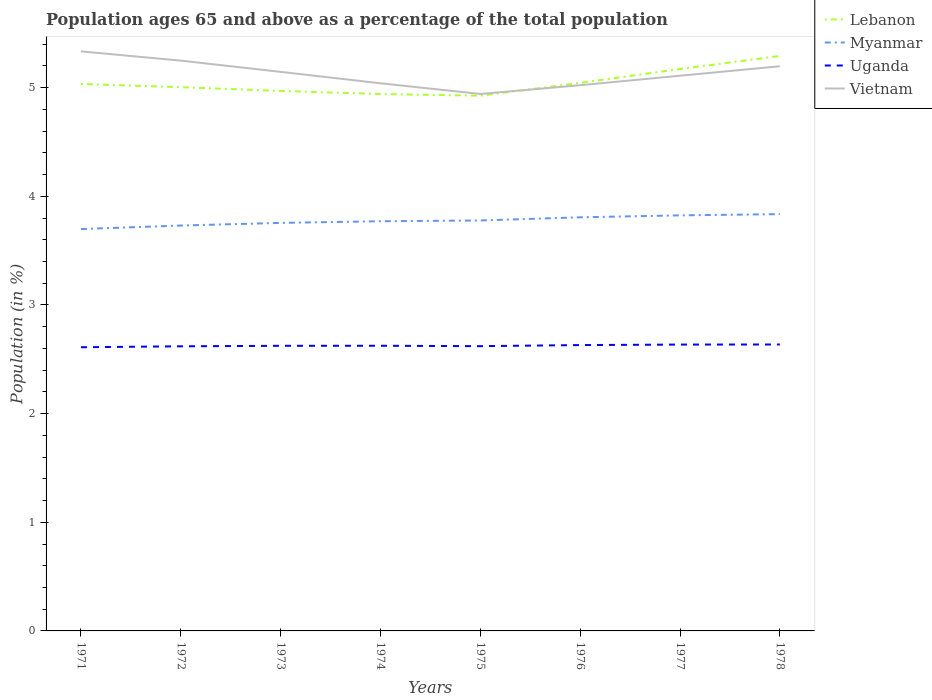How many different coloured lines are there?
Your response must be concise. 4. Does the line corresponding to Myanmar intersect with the line corresponding to Vietnam?
Make the answer very short. No. Is the number of lines equal to the number of legend labels?
Make the answer very short. Yes. Across all years, what is the maximum percentage of the population ages 65 and above in Myanmar?
Your answer should be compact. 3.7. In which year was the percentage of the population ages 65 and above in Uganda maximum?
Provide a short and direct response. 1971. What is the total percentage of the population ages 65 and above in Myanmar in the graph?
Give a very brief answer. -0.09. What is the difference between the highest and the second highest percentage of the population ages 65 and above in Lebanon?
Your answer should be compact. 0.37. How many lines are there?
Your response must be concise. 4. Are the values on the major ticks of Y-axis written in scientific E-notation?
Give a very brief answer. No. Where does the legend appear in the graph?
Make the answer very short. Top right. How many legend labels are there?
Your answer should be very brief. 4. How are the legend labels stacked?
Provide a succinct answer. Vertical. What is the title of the graph?
Provide a short and direct response. Population ages 65 and above as a percentage of the total population. What is the label or title of the Y-axis?
Keep it short and to the point. Population (in %). What is the Population (in %) of Lebanon in 1971?
Provide a succinct answer. 5.03. What is the Population (in %) in Myanmar in 1971?
Ensure brevity in your answer.  3.7. What is the Population (in %) of Uganda in 1971?
Your answer should be compact. 2.61. What is the Population (in %) of Vietnam in 1971?
Offer a very short reply. 5.33. What is the Population (in %) in Lebanon in 1972?
Ensure brevity in your answer.  5. What is the Population (in %) of Myanmar in 1972?
Your answer should be compact. 3.73. What is the Population (in %) of Uganda in 1972?
Provide a succinct answer. 2.62. What is the Population (in %) in Vietnam in 1972?
Your answer should be compact. 5.25. What is the Population (in %) in Lebanon in 1973?
Offer a terse response. 4.97. What is the Population (in %) of Myanmar in 1973?
Ensure brevity in your answer.  3.76. What is the Population (in %) of Uganda in 1973?
Offer a terse response. 2.62. What is the Population (in %) of Vietnam in 1973?
Give a very brief answer. 5.15. What is the Population (in %) in Lebanon in 1974?
Your response must be concise. 4.94. What is the Population (in %) of Myanmar in 1974?
Your answer should be compact. 3.77. What is the Population (in %) of Uganda in 1974?
Provide a short and direct response. 2.62. What is the Population (in %) in Vietnam in 1974?
Your answer should be compact. 5.04. What is the Population (in %) in Lebanon in 1975?
Offer a very short reply. 4.93. What is the Population (in %) in Myanmar in 1975?
Provide a succinct answer. 3.78. What is the Population (in %) of Uganda in 1975?
Offer a very short reply. 2.62. What is the Population (in %) of Vietnam in 1975?
Ensure brevity in your answer.  4.94. What is the Population (in %) in Lebanon in 1976?
Your answer should be very brief. 5.04. What is the Population (in %) of Myanmar in 1976?
Ensure brevity in your answer.  3.81. What is the Population (in %) of Uganda in 1976?
Make the answer very short. 2.63. What is the Population (in %) in Vietnam in 1976?
Provide a short and direct response. 5.02. What is the Population (in %) in Lebanon in 1977?
Keep it short and to the point. 5.17. What is the Population (in %) in Myanmar in 1977?
Make the answer very short. 3.82. What is the Population (in %) of Uganda in 1977?
Offer a terse response. 2.64. What is the Population (in %) of Vietnam in 1977?
Offer a very short reply. 5.11. What is the Population (in %) in Lebanon in 1978?
Your answer should be compact. 5.29. What is the Population (in %) in Myanmar in 1978?
Ensure brevity in your answer.  3.84. What is the Population (in %) of Uganda in 1978?
Give a very brief answer. 2.64. What is the Population (in %) of Vietnam in 1978?
Provide a succinct answer. 5.2. Across all years, what is the maximum Population (in %) in Lebanon?
Provide a succinct answer. 5.29. Across all years, what is the maximum Population (in %) of Myanmar?
Offer a terse response. 3.84. Across all years, what is the maximum Population (in %) in Uganda?
Offer a very short reply. 2.64. Across all years, what is the maximum Population (in %) in Vietnam?
Keep it short and to the point. 5.33. Across all years, what is the minimum Population (in %) in Lebanon?
Offer a very short reply. 4.93. Across all years, what is the minimum Population (in %) in Myanmar?
Offer a very short reply. 3.7. Across all years, what is the minimum Population (in %) in Uganda?
Keep it short and to the point. 2.61. Across all years, what is the minimum Population (in %) of Vietnam?
Ensure brevity in your answer.  4.94. What is the total Population (in %) of Lebanon in the graph?
Provide a succinct answer. 40.38. What is the total Population (in %) of Myanmar in the graph?
Keep it short and to the point. 30.2. What is the total Population (in %) in Uganda in the graph?
Make the answer very short. 21. What is the total Population (in %) in Vietnam in the graph?
Keep it short and to the point. 41.04. What is the difference between the Population (in %) in Lebanon in 1971 and that in 1972?
Your answer should be very brief. 0.03. What is the difference between the Population (in %) of Myanmar in 1971 and that in 1972?
Provide a succinct answer. -0.03. What is the difference between the Population (in %) of Uganda in 1971 and that in 1972?
Your answer should be very brief. -0.01. What is the difference between the Population (in %) in Vietnam in 1971 and that in 1972?
Keep it short and to the point. 0.09. What is the difference between the Population (in %) in Lebanon in 1971 and that in 1973?
Make the answer very short. 0.06. What is the difference between the Population (in %) in Myanmar in 1971 and that in 1973?
Offer a terse response. -0.06. What is the difference between the Population (in %) of Uganda in 1971 and that in 1973?
Provide a succinct answer. -0.01. What is the difference between the Population (in %) in Vietnam in 1971 and that in 1973?
Your response must be concise. 0.19. What is the difference between the Population (in %) of Lebanon in 1971 and that in 1974?
Give a very brief answer. 0.09. What is the difference between the Population (in %) of Myanmar in 1971 and that in 1974?
Your answer should be compact. -0.07. What is the difference between the Population (in %) in Uganda in 1971 and that in 1974?
Ensure brevity in your answer.  -0.01. What is the difference between the Population (in %) in Vietnam in 1971 and that in 1974?
Provide a succinct answer. 0.29. What is the difference between the Population (in %) of Lebanon in 1971 and that in 1975?
Offer a terse response. 0.11. What is the difference between the Population (in %) of Myanmar in 1971 and that in 1975?
Offer a very short reply. -0.08. What is the difference between the Population (in %) in Uganda in 1971 and that in 1975?
Offer a very short reply. -0.01. What is the difference between the Population (in %) in Vietnam in 1971 and that in 1975?
Make the answer very short. 0.39. What is the difference between the Population (in %) of Lebanon in 1971 and that in 1976?
Offer a terse response. -0.01. What is the difference between the Population (in %) of Myanmar in 1971 and that in 1976?
Make the answer very short. -0.11. What is the difference between the Population (in %) of Uganda in 1971 and that in 1976?
Offer a terse response. -0.02. What is the difference between the Population (in %) of Vietnam in 1971 and that in 1976?
Give a very brief answer. 0.31. What is the difference between the Population (in %) in Lebanon in 1971 and that in 1977?
Provide a succinct answer. -0.14. What is the difference between the Population (in %) in Myanmar in 1971 and that in 1977?
Offer a terse response. -0.13. What is the difference between the Population (in %) in Uganda in 1971 and that in 1977?
Your answer should be very brief. -0.02. What is the difference between the Population (in %) of Vietnam in 1971 and that in 1977?
Your answer should be compact. 0.22. What is the difference between the Population (in %) in Lebanon in 1971 and that in 1978?
Provide a short and direct response. -0.26. What is the difference between the Population (in %) of Myanmar in 1971 and that in 1978?
Your answer should be compact. -0.14. What is the difference between the Population (in %) of Uganda in 1971 and that in 1978?
Provide a short and direct response. -0.03. What is the difference between the Population (in %) in Vietnam in 1971 and that in 1978?
Make the answer very short. 0.14. What is the difference between the Population (in %) of Lebanon in 1972 and that in 1973?
Your response must be concise. 0.03. What is the difference between the Population (in %) in Myanmar in 1972 and that in 1973?
Make the answer very short. -0.02. What is the difference between the Population (in %) in Uganda in 1972 and that in 1973?
Your answer should be compact. -0. What is the difference between the Population (in %) in Vietnam in 1972 and that in 1973?
Make the answer very short. 0.1. What is the difference between the Population (in %) of Lebanon in 1972 and that in 1974?
Your answer should be compact. 0.06. What is the difference between the Population (in %) in Myanmar in 1972 and that in 1974?
Your response must be concise. -0.04. What is the difference between the Population (in %) of Uganda in 1972 and that in 1974?
Offer a very short reply. -0.01. What is the difference between the Population (in %) of Vietnam in 1972 and that in 1974?
Keep it short and to the point. 0.21. What is the difference between the Population (in %) in Lebanon in 1972 and that in 1975?
Your answer should be very brief. 0.08. What is the difference between the Population (in %) of Myanmar in 1972 and that in 1975?
Your response must be concise. -0.05. What is the difference between the Population (in %) of Uganda in 1972 and that in 1975?
Your answer should be compact. -0. What is the difference between the Population (in %) in Vietnam in 1972 and that in 1975?
Keep it short and to the point. 0.31. What is the difference between the Population (in %) of Lebanon in 1972 and that in 1976?
Provide a succinct answer. -0.04. What is the difference between the Population (in %) of Myanmar in 1972 and that in 1976?
Provide a succinct answer. -0.08. What is the difference between the Population (in %) of Uganda in 1972 and that in 1976?
Your response must be concise. -0.01. What is the difference between the Population (in %) in Vietnam in 1972 and that in 1976?
Offer a very short reply. 0.23. What is the difference between the Population (in %) of Lebanon in 1972 and that in 1977?
Your answer should be very brief. -0.17. What is the difference between the Population (in %) in Myanmar in 1972 and that in 1977?
Your response must be concise. -0.09. What is the difference between the Population (in %) of Uganda in 1972 and that in 1977?
Keep it short and to the point. -0.02. What is the difference between the Population (in %) of Vietnam in 1972 and that in 1977?
Your response must be concise. 0.14. What is the difference between the Population (in %) of Lebanon in 1972 and that in 1978?
Keep it short and to the point. -0.29. What is the difference between the Population (in %) of Myanmar in 1972 and that in 1978?
Your answer should be compact. -0.1. What is the difference between the Population (in %) in Uganda in 1972 and that in 1978?
Provide a succinct answer. -0.02. What is the difference between the Population (in %) in Vietnam in 1972 and that in 1978?
Provide a short and direct response. 0.05. What is the difference between the Population (in %) in Lebanon in 1973 and that in 1974?
Provide a succinct answer. 0.03. What is the difference between the Population (in %) of Myanmar in 1973 and that in 1974?
Your answer should be very brief. -0.02. What is the difference between the Population (in %) in Uganda in 1973 and that in 1974?
Your answer should be very brief. -0. What is the difference between the Population (in %) of Vietnam in 1973 and that in 1974?
Ensure brevity in your answer.  0.11. What is the difference between the Population (in %) in Lebanon in 1973 and that in 1975?
Give a very brief answer. 0.04. What is the difference between the Population (in %) in Myanmar in 1973 and that in 1975?
Ensure brevity in your answer.  -0.02. What is the difference between the Population (in %) in Uganda in 1973 and that in 1975?
Ensure brevity in your answer.  0. What is the difference between the Population (in %) of Vietnam in 1973 and that in 1975?
Make the answer very short. 0.2. What is the difference between the Population (in %) of Lebanon in 1973 and that in 1976?
Keep it short and to the point. -0.07. What is the difference between the Population (in %) in Myanmar in 1973 and that in 1976?
Keep it short and to the point. -0.05. What is the difference between the Population (in %) of Uganda in 1973 and that in 1976?
Provide a succinct answer. -0.01. What is the difference between the Population (in %) of Vietnam in 1973 and that in 1976?
Your answer should be very brief. 0.12. What is the difference between the Population (in %) of Lebanon in 1973 and that in 1977?
Ensure brevity in your answer.  -0.2. What is the difference between the Population (in %) in Myanmar in 1973 and that in 1977?
Ensure brevity in your answer.  -0.07. What is the difference between the Population (in %) of Uganda in 1973 and that in 1977?
Give a very brief answer. -0.01. What is the difference between the Population (in %) in Vietnam in 1973 and that in 1977?
Ensure brevity in your answer.  0.04. What is the difference between the Population (in %) in Lebanon in 1973 and that in 1978?
Keep it short and to the point. -0.32. What is the difference between the Population (in %) in Myanmar in 1973 and that in 1978?
Your response must be concise. -0.08. What is the difference between the Population (in %) of Uganda in 1973 and that in 1978?
Keep it short and to the point. -0.01. What is the difference between the Population (in %) of Vietnam in 1973 and that in 1978?
Your answer should be compact. -0.05. What is the difference between the Population (in %) in Lebanon in 1974 and that in 1975?
Offer a terse response. 0.02. What is the difference between the Population (in %) of Myanmar in 1974 and that in 1975?
Your answer should be very brief. -0.01. What is the difference between the Population (in %) in Uganda in 1974 and that in 1975?
Your response must be concise. 0. What is the difference between the Population (in %) in Vietnam in 1974 and that in 1975?
Your answer should be very brief. 0.1. What is the difference between the Population (in %) of Lebanon in 1974 and that in 1976?
Your answer should be compact. -0.1. What is the difference between the Population (in %) in Myanmar in 1974 and that in 1976?
Provide a short and direct response. -0.04. What is the difference between the Population (in %) in Uganda in 1974 and that in 1976?
Ensure brevity in your answer.  -0.01. What is the difference between the Population (in %) in Vietnam in 1974 and that in 1976?
Make the answer very short. 0.02. What is the difference between the Population (in %) of Lebanon in 1974 and that in 1977?
Offer a very short reply. -0.23. What is the difference between the Population (in %) of Myanmar in 1974 and that in 1977?
Provide a short and direct response. -0.05. What is the difference between the Population (in %) in Uganda in 1974 and that in 1977?
Offer a terse response. -0.01. What is the difference between the Population (in %) of Vietnam in 1974 and that in 1977?
Offer a terse response. -0.07. What is the difference between the Population (in %) in Lebanon in 1974 and that in 1978?
Provide a succinct answer. -0.35. What is the difference between the Population (in %) in Myanmar in 1974 and that in 1978?
Ensure brevity in your answer.  -0.07. What is the difference between the Population (in %) of Uganda in 1974 and that in 1978?
Provide a succinct answer. -0.01. What is the difference between the Population (in %) of Vietnam in 1974 and that in 1978?
Offer a terse response. -0.16. What is the difference between the Population (in %) of Lebanon in 1975 and that in 1976?
Your answer should be compact. -0.12. What is the difference between the Population (in %) of Myanmar in 1975 and that in 1976?
Offer a very short reply. -0.03. What is the difference between the Population (in %) in Uganda in 1975 and that in 1976?
Make the answer very short. -0.01. What is the difference between the Population (in %) in Vietnam in 1975 and that in 1976?
Offer a terse response. -0.08. What is the difference between the Population (in %) of Lebanon in 1975 and that in 1977?
Ensure brevity in your answer.  -0.25. What is the difference between the Population (in %) in Myanmar in 1975 and that in 1977?
Give a very brief answer. -0.05. What is the difference between the Population (in %) in Uganda in 1975 and that in 1977?
Offer a terse response. -0.01. What is the difference between the Population (in %) in Vietnam in 1975 and that in 1977?
Provide a short and direct response. -0.17. What is the difference between the Population (in %) in Lebanon in 1975 and that in 1978?
Give a very brief answer. -0.37. What is the difference between the Population (in %) of Myanmar in 1975 and that in 1978?
Offer a very short reply. -0.06. What is the difference between the Population (in %) of Uganda in 1975 and that in 1978?
Offer a very short reply. -0.02. What is the difference between the Population (in %) in Vietnam in 1975 and that in 1978?
Make the answer very short. -0.25. What is the difference between the Population (in %) of Lebanon in 1976 and that in 1977?
Your answer should be very brief. -0.13. What is the difference between the Population (in %) of Myanmar in 1976 and that in 1977?
Your answer should be very brief. -0.02. What is the difference between the Population (in %) in Uganda in 1976 and that in 1977?
Ensure brevity in your answer.  -0. What is the difference between the Population (in %) of Vietnam in 1976 and that in 1977?
Give a very brief answer. -0.09. What is the difference between the Population (in %) of Lebanon in 1976 and that in 1978?
Ensure brevity in your answer.  -0.25. What is the difference between the Population (in %) in Myanmar in 1976 and that in 1978?
Offer a very short reply. -0.03. What is the difference between the Population (in %) in Uganda in 1976 and that in 1978?
Your response must be concise. -0.01. What is the difference between the Population (in %) of Vietnam in 1976 and that in 1978?
Keep it short and to the point. -0.17. What is the difference between the Population (in %) of Lebanon in 1977 and that in 1978?
Keep it short and to the point. -0.12. What is the difference between the Population (in %) of Myanmar in 1977 and that in 1978?
Your answer should be compact. -0.01. What is the difference between the Population (in %) in Uganda in 1977 and that in 1978?
Ensure brevity in your answer.  -0. What is the difference between the Population (in %) of Vietnam in 1977 and that in 1978?
Your answer should be very brief. -0.09. What is the difference between the Population (in %) in Lebanon in 1971 and the Population (in %) in Myanmar in 1972?
Give a very brief answer. 1.3. What is the difference between the Population (in %) in Lebanon in 1971 and the Population (in %) in Uganda in 1972?
Give a very brief answer. 2.41. What is the difference between the Population (in %) in Lebanon in 1971 and the Population (in %) in Vietnam in 1972?
Ensure brevity in your answer.  -0.22. What is the difference between the Population (in %) of Myanmar in 1971 and the Population (in %) of Uganda in 1972?
Keep it short and to the point. 1.08. What is the difference between the Population (in %) in Myanmar in 1971 and the Population (in %) in Vietnam in 1972?
Ensure brevity in your answer.  -1.55. What is the difference between the Population (in %) of Uganda in 1971 and the Population (in %) of Vietnam in 1972?
Provide a succinct answer. -2.64. What is the difference between the Population (in %) in Lebanon in 1971 and the Population (in %) in Myanmar in 1973?
Your response must be concise. 1.28. What is the difference between the Population (in %) of Lebanon in 1971 and the Population (in %) of Uganda in 1973?
Provide a short and direct response. 2.41. What is the difference between the Population (in %) of Lebanon in 1971 and the Population (in %) of Vietnam in 1973?
Provide a short and direct response. -0.11. What is the difference between the Population (in %) of Myanmar in 1971 and the Population (in %) of Uganda in 1973?
Provide a succinct answer. 1.07. What is the difference between the Population (in %) of Myanmar in 1971 and the Population (in %) of Vietnam in 1973?
Your answer should be compact. -1.45. What is the difference between the Population (in %) of Uganda in 1971 and the Population (in %) of Vietnam in 1973?
Provide a succinct answer. -2.53. What is the difference between the Population (in %) of Lebanon in 1971 and the Population (in %) of Myanmar in 1974?
Give a very brief answer. 1.26. What is the difference between the Population (in %) of Lebanon in 1971 and the Population (in %) of Uganda in 1974?
Make the answer very short. 2.41. What is the difference between the Population (in %) of Lebanon in 1971 and the Population (in %) of Vietnam in 1974?
Your answer should be compact. -0.01. What is the difference between the Population (in %) in Myanmar in 1971 and the Population (in %) in Uganda in 1974?
Make the answer very short. 1.07. What is the difference between the Population (in %) in Myanmar in 1971 and the Population (in %) in Vietnam in 1974?
Your response must be concise. -1.34. What is the difference between the Population (in %) in Uganda in 1971 and the Population (in %) in Vietnam in 1974?
Ensure brevity in your answer.  -2.43. What is the difference between the Population (in %) of Lebanon in 1971 and the Population (in %) of Myanmar in 1975?
Give a very brief answer. 1.26. What is the difference between the Population (in %) in Lebanon in 1971 and the Population (in %) in Uganda in 1975?
Your answer should be compact. 2.41. What is the difference between the Population (in %) in Lebanon in 1971 and the Population (in %) in Vietnam in 1975?
Ensure brevity in your answer.  0.09. What is the difference between the Population (in %) in Myanmar in 1971 and the Population (in %) in Uganda in 1975?
Ensure brevity in your answer.  1.08. What is the difference between the Population (in %) of Myanmar in 1971 and the Population (in %) of Vietnam in 1975?
Offer a terse response. -1.24. What is the difference between the Population (in %) of Uganda in 1971 and the Population (in %) of Vietnam in 1975?
Offer a very short reply. -2.33. What is the difference between the Population (in %) in Lebanon in 1971 and the Population (in %) in Myanmar in 1976?
Your response must be concise. 1.23. What is the difference between the Population (in %) in Lebanon in 1971 and the Population (in %) in Uganda in 1976?
Offer a very short reply. 2.4. What is the difference between the Population (in %) in Lebanon in 1971 and the Population (in %) in Vietnam in 1976?
Provide a succinct answer. 0.01. What is the difference between the Population (in %) in Myanmar in 1971 and the Population (in %) in Uganda in 1976?
Offer a terse response. 1.07. What is the difference between the Population (in %) in Myanmar in 1971 and the Population (in %) in Vietnam in 1976?
Ensure brevity in your answer.  -1.32. What is the difference between the Population (in %) of Uganda in 1971 and the Population (in %) of Vietnam in 1976?
Offer a very short reply. -2.41. What is the difference between the Population (in %) of Lebanon in 1971 and the Population (in %) of Myanmar in 1977?
Your answer should be compact. 1.21. What is the difference between the Population (in %) of Lebanon in 1971 and the Population (in %) of Uganda in 1977?
Provide a short and direct response. 2.4. What is the difference between the Population (in %) of Lebanon in 1971 and the Population (in %) of Vietnam in 1977?
Give a very brief answer. -0.08. What is the difference between the Population (in %) in Myanmar in 1971 and the Population (in %) in Uganda in 1977?
Offer a very short reply. 1.06. What is the difference between the Population (in %) in Myanmar in 1971 and the Population (in %) in Vietnam in 1977?
Offer a terse response. -1.41. What is the difference between the Population (in %) in Uganda in 1971 and the Population (in %) in Vietnam in 1977?
Keep it short and to the point. -2.5. What is the difference between the Population (in %) in Lebanon in 1971 and the Population (in %) in Myanmar in 1978?
Your answer should be compact. 1.2. What is the difference between the Population (in %) of Lebanon in 1971 and the Population (in %) of Uganda in 1978?
Provide a succinct answer. 2.4. What is the difference between the Population (in %) in Lebanon in 1971 and the Population (in %) in Vietnam in 1978?
Give a very brief answer. -0.16. What is the difference between the Population (in %) of Myanmar in 1971 and the Population (in %) of Uganda in 1978?
Provide a short and direct response. 1.06. What is the difference between the Population (in %) of Myanmar in 1971 and the Population (in %) of Vietnam in 1978?
Provide a succinct answer. -1.5. What is the difference between the Population (in %) of Uganda in 1971 and the Population (in %) of Vietnam in 1978?
Ensure brevity in your answer.  -2.59. What is the difference between the Population (in %) in Lebanon in 1972 and the Population (in %) in Myanmar in 1973?
Provide a succinct answer. 1.25. What is the difference between the Population (in %) of Lebanon in 1972 and the Population (in %) of Uganda in 1973?
Offer a terse response. 2.38. What is the difference between the Population (in %) in Lebanon in 1972 and the Population (in %) in Vietnam in 1973?
Your answer should be very brief. -0.14. What is the difference between the Population (in %) of Myanmar in 1972 and the Population (in %) of Uganda in 1973?
Offer a terse response. 1.11. What is the difference between the Population (in %) in Myanmar in 1972 and the Population (in %) in Vietnam in 1973?
Give a very brief answer. -1.41. What is the difference between the Population (in %) of Uganda in 1972 and the Population (in %) of Vietnam in 1973?
Your answer should be very brief. -2.53. What is the difference between the Population (in %) in Lebanon in 1972 and the Population (in %) in Myanmar in 1974?
Offer a very short reply. 1.23. What is the difference between the Population (in %) of Lebanon in 1972 and the Population (in %) of Uganda in 1974?
Give a very brief answer. 2.38. What is the difference between the Population (in %) of Lebanon in 1972 and the Population (in %) of Vietnam in 1974?
Provide a succinct answer. -0.04. What is the difference between the Population (in %) of Myanmar in 1972 and the Population (in %) of Uganda in 1974?
Give a very brief answer. 1.11. What is the difference between the Population (in %) of Myanmar in 1972 and the Population (in %) of Vietnam in 1974?
Your response must be concise. -1.31. What is the difference between the Population (in %) of Uganda in 1972 and the Population (in %) of Vietnam in 1974?
Ensure brevity in your answer.  -2.42. What is the difference between the Population (in %) of Lebanon in 1972 and the Population (in %) of Myanmar in 1975?
Provide a short and direct response. 1.23. What is the difference between the Population (in %) of Lebanon in 1972 and the Population (in %) of Uganda in 1975?
Make the answer very short. 2.38. What is the difference between the Population (in %) in Lebanon in 1972 and the Population (in %) in Vietnam in 1975?
Provide a short and direct response. 0.06. What is the difference between the Population (in %) of Myanmar in 1972 and the Population (in %) of Uganda in 1975?
Provide a succinct answer. 1.11. What is the difference between the Population (in %) of Myanmar in 1972 and the Population (in %) of Vietnam in 1975?
Provide a short and direct response. -1.21. What is the difference between the Population (in %) in Uganda in 1972 and the Population (in %) in Vietnam in 1975?
Keep it short and to the point. -2.32. What is the difference between the Population (in %) of Lebanon in 1972 and the Population (in %) of Myanmar in 1976?
Keep it short and to the point. 1.2. What is the difference between the Population (in %) of Lebanon in 1972 and the Population (in %) of Uganda in 1976?
Offer a terse response. 2.37. What is the difference between the Population (in %) of Lebanon in 1972 and the Population (in %) of Vietnam in 1976?
Offer a very short reply. -0.02. What is the difference between the Population (in %) of Myanmar in 1972 and the Population (in %) of Uganda in 1976?
Provide a succinct answer. 1.1. What is the difference between the Population (in %) in Myanmar in 1972 and the Population (in %) in Vietnam in 1976?
Your answer should be compact. -1.29. What is the difference between the Population (in %) in Uganda in 1972 and the Population (in %) in Vietnam in 1976?
Give a very brief answer. -2.4. What is the difference between the Population (in %) in Lebanon in 1972 and the Population (in %) in Myanmar in 1977?
Your answer should be compact. 1.18. What is the difference between the Population (in %) in Lebanon in 1972 and the Population (in %) in Uganda in 1977?
Keep it short and to the point. 2.37. What is the difference between the Population (in %) in Lebanon in 1972 and the Population (in %) in Vietnam in 1977?
Offer a very short reply. -0.11. What is the difference between the Population (in %) in Myanmar in 1972 and the Population (in %) in Uganda in 1977?
Your answer should be very brief. 1.1. What is the difference between the Population (in %) of Myanmar in 1972 and the Population (in %) of Vietnam in 1977?
Ensure brevity in your answer.  -1.38. What is the difference between the Population (in %) of Uganda in 1972 and the Population (in %) of Vietnam in 1977?
Provide a succinct answer. -2.49. What is the difference between the Population (in %) in Lebanon in 1972 and the Population (in %) in Myanmar in 1978?
Provide a short and direct response. 1.17. What is the difference between the Population (in %) in Lebanon in 1972 and the Population (in %) in Uganda in 1978?
Provide a short and direct response. 2.37. What is the difference between the Population (in %) in Lebanon in 1972 and the Population (in %) in Vietnam in 1978?
Your response must be concise. -0.19. What is the difference between the Population (in %) of Myanmar in 1972 and the Population (in %) of Uganda in 1978?
Give a very brief answer. 1.09. What is the difference between the Population (in %) in Myanmar in 1972 and the Population (in %) in Vietnam in 1978?
Offer a very short reply. -1.47. What is the difference between the Population (in %) in Uganda in 1972 and the Population (in %) in Vietnam in 1978?
Provide a succinct answer. -2.58. What is the difference between the Population (in %) of Lebanon in 1973 and the Population (in %) of Myanmar in 1974?
Make the answer very short. 1.2. What is the difference between the Population (in %) in Lebanon in 1973 and the Population (in %) in Uganda in 1974?
Your answer should be compact. 2.35. What is the difference between the Population (in %) of Lebanon in 1973 and the Population (in %) of Vietnam in 1974?
Provide a succinct answer. -0.07. What is the difference between the Population (in %) of Myanmar in 1973 and the Population (in %) of Uganda in 1974?
Your answer should be compact. 1.13. What is the difference between the Population (in %) in Myanmar in 1973 and the Population (in %) in Vietnam in 1974?
Ensure brevity in your answer.  -1.28. What is the difference between the Population (in %) in Uganda in 1973 and the Population (in %) in Vietnam in 1974?
Provide a short and direct response. -2.42. What is the difference between the Population (in %) of Lebanon in 1973 and the Population (in %) of Myanmar in 1975?
Your response must be concise. 1.19. What is the difference between the Population (in %) of Lebanon in 1973 and the Population (in %) of Uganda in 1975?
Your response must be concise. 2.35. What is the difference between the Population (in %) in Lebanon in 1973 and the Population (in %) in Vietnam in 1975?
Offer a terse response. 0.03. What is the difference between the Population (in %) in Myanmar in 1973 and the Population (in %) in Uganda in 1975?
Ensure brevity in your answer.  1.13. What is the difference between the Population (in %) in Myanmar in 1973 and the Population (in %) in Vietnam in 1975?
Your response must be concise. -1.19. What is the difference between the Population (in %) in Uganda in 1973 and the Population (in %) in Vietnam in 1975?
Your answer should be very brief. -2.32. What is the difference between the Population (in %) of Lebanon in 1973 and the Population (in %) of Myanmar in 1976?
Your answer should be very brief. 1.16. What is the difference between the Population (in %) of Lebanon in 1973 and the Population (in %) of Uganda in 1976?
Keep it short and to the point. 2.34. What is the difference between the Population (in %) of Lebanon in 1973 and the Population (in %) of Vietnam in 1976?
Provide a succinct answer. -0.05. What is the difference between the Population (in %) in Myanmar in 1973 and the Population (in %) in Uganda in 1976?
Offer a terse response. 1.12. What is the difference between the Population (in %) of Myanmar in 1973 and the Population (in %) of Vietnam in 1976?
Give a very brief answer. -1.27. What is the difference between the Population (in %) of Uganda in 1973 and the Population (in %) of Vietnam in 1976?
Keep it short and to the point. -2.4. What is the difference between the Population (in %) of Lebanon in 1973 and the Population (in %) of Myanmar in 1977?
Keep it short and to the point. 1.15. What is the difference between the Population (in %) of Lebanon in 1973 and the Population (in %) of Uganda in 1977?
Provide a succinct answer. 2.33. What is the difference between the Population (in %) in Lebanon in 1973 and the Population (in %) in Vietnam in 1977?
Give a very brief answer. -0.14. What is the difference between the Population (in %) in Myanmar in 1973 and the Population (in %) in Uganda in 1977?
Ensure brevity in your answer.  1.12. What is the difference between the Population (in %) of Myanmar in 1973 and the Population (in %) of Vietnam in 1977?
Your answer should be very brief. -1.35. What is the difference between the Population (in %) in Uganda in 1973 and the Population (in %) in Vietnam in 1977?
Your answer should be very brief. -2.49. What is the difference between the Population (in %) in Lebanon in 1973 and the Population (in %) in Myanmar in 1978?
Offer a very short reply. 1.13. What is the difference between the Population (in %) in Lebanon in 1973 and the Population (in %) in Uganda in 1978?
Give a very brief answer. 2.33. What is the difference between the Population (in %) in Lebanon in 1973 and the Population (in %) in Vietnam in 1978?
Your answer should be compact. -0.23. What is the difference between the Population (in %) in Myanmar in 1973 and the Population (in %) in Uganda in 1978?
Provide a succinct answer. 1.12. What is the difference between the Population (in %) of Myanmar in 1973 and the Population (in %) of Vietnam in 1978?
Offer a terse response. -1.44. What is the difference between the Population (in %) of Uganda in 1973 and the Population (in %) of Vietnam in 1978?
Your answer should be very brief. -2.57. What is the difference between the Population (in %) of Lebanon in 1974 and the Population (in %) of Myanmar in 1975?
Make the answer very short. 1.16. What is the difference between the Population (in %) of Lebanon in 1974 and the Population (in %) of Uganda in 1975?
Provide a short and direct response. 2.32. What is the difference between the Population (in %) in Lebanon in 1974 and the Population (in %) in Vietnam in 1975?
Keep it short and to the point. -0. What is the difference between the Population (in %) of Myanmar in 1974 and the Population (in %) of Uganda in 1975?
Your answer should be very brief. 1.15. What is the difference between the Population (in %) in Myanmar in 1974 and the Population (in %) in Vietnam in 1975?
Your answer should be very brief. -1.17. What is the difference between the Population (in %) in Uganda in 1974 and the Population (in %) in Vietnam in 1975?
Provide a succinct answer. -2.32. What is the difference between the Population (in %) of Lebanon in 1974 and the Population (in %) of Myanmar in 1976?
Offer a terse response. 1.13. What is the difference between the Population (in %) in Lebanon in 1974 and the Population (in %) in Uganda in 1976?
Give a very brief answer. 2.31. What is the difference between the Population (in %) in Lebanon in 1974 and the Population (in %) in Vietnam in 1976?
Ensure brevity in your answer.  -0.08. What is the difference between the Population (in %) in Myanmar in 1974 and the Population (in %) in Uganda in 1976?
Keep it short and to the point. 1.14. What is the difference between the Population (in %) of Myanmar in 1974 and the Population (in %) of Vietnam in 1976?
Offer a very short reply. -1.25. What is the difference between the Population (in %) in Uganda in 1974 and the Population (in %) in Vietnam in 1976?
Keep it short and to the point. -2.4. What is the difference between the Population (in %) of Lebanon in 1974 and the Population (in %) of Myanmar in 1977?
Ensure brevity in your answer.  1.12. What is the difference between the Population (in %) of Lebanon in 1974 and the Population (in %) of Uganda in 1977?
Provide a short and direct response. 2.31. What is the difference between the Population (in %) of Lebanon in 1974 and the Population (in %) of Vietnam in 1977?
Offer a terse response. -0.17. What is the difference between the Population (in %) of Myanmar in 1974 and the Population (in %) of Uganda in 1977?
Give a very brief answer. 1.14. What is the difference between the Population (in %) of Myanmar in 1974 and the Population (in %) of Vietnam in 1977?
Ensure brevity in your answer.  -1.34. What is the difference between the Population (in %) in Uganda in 1974 and the Population (in %) in Vietnam in 1977?
Your response must be concise. -2.49. What is the difference between the Population (in %) in Lebanon in 1974 and the Population (in %) in Myanmar in 1978?
Provide a short and direct response. 1.11. What is the difference between the Population (in %) of Lebanon in 1974 and the Population (in %) of Uganda in 1978?
Provide a short and direct response. 2.31. What is the difference between the Population (in %) in Lebanon in 1974 and the Population (in %) in Vietnam in 1978?
Offer a very short reply. -0.26. What is the difference between the Population (in %) in Myanmar in 1974 and the Population (in %) in Uganda in 1978?
Offer a very short reply. 1.13. What is the difference between the Population (in %) of Myanmar in 1974 and the Population (in %) of Vietnam in 1978?
Keep it short and to the point. -1.43. What is the difference between the Population (in %) of Uganda in 1974 and the Population (in %) of Vietnam in 1978?
Give a very brief answer. -2.57. What is the difference between the Population (in %) of Lebanon in 1975 and the Population (in %) of Myanmar in 1976?
Offer a very short reply. 1.12. What is the difference between the Population (in %) in Lebanon in 1975 and the Population (in %) in Uganda in 1976?
Provide a short and direct response. 2.3. What is the difference between the Population (in %) of Lebanon in 1975 and the Population (in %) of Vietnam in 1976?
Offer a very short reply. -0.1. What is the difference between the Population (in %) in Myanmar in 1975 and the Population (in %) in Uganda in 1976?
Offer a very short reply. 1.15. What is the difference between the Population (in %) of Myanmar in 1975 and the Population (in %) of Vietnam in 1976?
Make the answer very short. -1.24. What is the difference between the Population (in %) in Uganda in 1975 and the Population (in %) in Vietnam in 1976?
Keep it short and to the point. -2.4. What is the difference between the Population (in %) in Lebanon in 1975 and the Population (in %) in Myanmar in 1977?
Your answer should be compact. 1.1. What is the difference between the Population (in %) in Lebanon in 1975 and the Population (in %) in Uganda in 1977?
Make the answer very short. 2.29. What is the difference between the Population (in %) in Lebanon in 1975 and the Population (in %) in Vietnam in 1977?
Offer a terse response. -0.18. What is the difference between the Population (in %) in Myanmar in 1975 and the Population (in %) in Uganda in 1977?
Your answer should be compact. 1.14. What is the difference between the Population (in %) of Myanmar in 1975 and the Population (in %) of Vietnam in 1977?
Your response must be concise. -1.33. What is the difference between the Population (in %) in Uganda in 1975 and the Population (in %) in Vietnam in 1977?
Offer a terse response. -2.49. What is the difference between the Population (in %) in Lebanon in 1975 and the Population (in %) in Myanmar in 1978?
Ensure brevity in your answer.  1.09. What is the difference between the Population (in %) of Lebanon in 1975 and the Population (in %) of Uganda in 1978?
Keep it short and to the point. 2.29. What is the difference between the Population (in %) of Lebanon in 1975 and the Population (in %) of Vietnam in 1978?
Give a very brief answer. -0.27. What is the difference between the Population (in %) of Myanmar in 1975 and the Population (in %) of Uganda in 1978?
Make the answer very short. 1.14. What is the difference between the Population (in %) in Myanmar in 1975 and the Population (in %) in Vietnam in 1978?
Provide a short and direct response. -1.42. What is the difference between the Population (in %) in Uganda in 1975 and the Population (in %) in Vietnam in 1978?
Your response must be concise. -2.58. What is the difference between the Population (in %) of Lebanon in 1976 and the Population (in %) of Myanmar in 1977?
Make the answer very short. 1.22. What is the difference between the Population (in %) of Lebanon in 1976 and the Population (in %) of Uganda in 1977?
Your answer should be compact. 2.41. What is the difference between the Population (in %) of Lebanon in 1976 and the Population (in %) of Vietnam in 1977?
Offer a terse response. -0.07. What is the difference between the Population (in %) in Myanmar in 1976 and the Population (in %) in Uganda in 1977?
Offer a terse response. 1.17. What is the difference between the Population (in %) in Myanmar in 1976 and the Population (in %) in Vietnam in 1977?
Your response must be concise. -1.3. What is the difference between the Population (in %) of Uganda in 1976 and the Population (in %) of Vietnam in 1977?
Offer a very short reply. -2.48. What is the difference between the Population (in %) of Lebanon in 1976 and the Population (in %) of Myanmar in 1978?
Your answer should be compact. 1.21. What is the difference between the Population (in %) of Lebanon in 1976 and the Population (in %) of Uganda in 1978?
Give a very brief answer. 2.41. What is the difference between the Population (in %) of Lebanon in 1976 and the Population (in %) of Vietnam in 1978?
Offer a terse response. -0.15. What is the difference between the Population (in %) of Myanmar in 1976 and the Population (in %) of Uganda in 1978?
Give a very brief answer. 1.17. What is the difference between the Population (in %) of Myanmar in 1976 and the Population (in %) of Vietnam in 1978?
Give a very brief answer. -1.39. What is the difference between the Population (in %) of Uganda in 1976 and the Population (in %) of Vietnam in 1978?
Your response must be concise. -2.57. What is the difference between the Population (in %) of Lebanon in 1977 and the Population (in %) of Myanmar in 1978?
Your answer should be compact. 1.34. What is the difference between the Population (in %) in Lebanon in 1977 and the Population (in %) in Uganda in 1978?
Your answer should be compact. 2.54. What is the difference between the Population (in %) of Lebanon in 1977 and the Population (in %) of Vietnam in 1978?
Provide a short and direct response. -0.03. What is the difference between the Population (in %) in Myanmar in 1977 and the Population (in %) in Uganda in 1978?
Offer a terse response. 1.19. What is the difference between the Population (in %) in Myanmar in 1977 and the Population (in %) in Vietnam in 1978?
Your response must be concise. -1.37. What is the difference between the Population (in %) of Uganda in 1977 and the Population (in %) of Vietnam in 1978?
Offer a terse response. -2.56. What is the average Population (in %) of Lebanon per year?
Make the answer very short. 5.05. What is the average Population (in %) of Myanmar per year?
Offer a terse response. 3.78. What is the average Population (in %) in Uganda per year?
Your answer should be compact. 2.63. What is the average Population (in %) in Vietnam per year?
Your answer should be very brief. 5.13. In the year 1971, what is the difference between the Population (in %) in Lebanon and Population (in %) in Myanmar?
Provide a succinct answer. 1.33. In the year 1971, what is the difference between the Population (in %) of Lebanon and Population (in %) of Uganda?
Give a very brief answer. 2.42. In the year 1971, what is the difference between the Population (in %) of Lebanon and Population (in %) of Vietnam?
Your answer should be very brief. -0.3. In the year 1971, what is the difference between the Population (in %) of Myanmar and Population (in %) of Uganda?
Make the answer very short. 1.09. In the year 1971, what is the difference between the Population (in %) of Myanmar and Population (in %) of Vietnam?
Offer a very short reply. -1.64. In the year 1971, what is the difference between the Population (in %) in Uganda and Population (in %) in Vietnam?
Your answer should be very brief. -2.72. In the year 1972, what is the difference between the Population (in %) of Lebanon and Population (in %) of Myanmar?
Offer a terse response. 1.27. In the year 1972, what is the difference between the Population (in %) in Lebanon and Population (in %) in Uganda?
Provide a succinct answer. 2.39. In the year 1972, what is the difference between the Population (in %) of Lebanon and Population (in %) of Vietnam?
Your answer should be very brief. -0.24. In the year 1972, what is the difference between the Population (in %) of Myanmar and Population (in %) of Uganda?
Your answer should be compact. 1.11. In the year 1972, what is the difference between the Population (in %) of Myanmar and Population (in %) of Vietnam?
Your answer should be compact. -1.52. In the year 1972, what is the difference between the Population (in %) in Uganda and Population (in %) in Vietnam?
Give a very brief answer. -2.63. In the year 1973, what is the difference between the Population (in %) of Lebanon and Population (in %) of Myanmar?
Your answer should be very brief. 1.21. In the year 1973, what is the difference between the Population (in %) in Lebanon and Population (in %) in Uganda?
Offer a terse response. 2.35. In the year 1973, what is the difference between the Population (in %) in Lebanon and Population (in %) in Vietnam?
Your answer should be very brief. -0.18. In the year 1973, what is the difference between the Population (in %) of Myanmar and Population (in %) of Uganda?
Offer a very short reply. 1.13. In the year 1973, what is the difference between the Population (in %) of Myanmar and Population (in %) of Vietnam?
Provide a short and direct response. -1.39. In the year 1973, what is the difference between the Population (in %) in Uganda and Population (in %) in Vietnam?
Keep it short and to the point. -2.52. In the year 1974, what is the difference between the Population (in %) in Lebanon and Population (in %) in Myanmar?
Offer a terse response. 1.17. In the year 1974, what is the difference between the Population (in %) of Lebanon and Population (in %) of Uganda?
Keep it short and to the point. 2.32. In the year 1974, what is the difference between the Population (in %) in Lebanon and Population (in %) in Vietnam?
Your answer should be very brief. -0.1. In the year 1974, what is the difference between the Population (in %) in Myanmar and Population (in %) in Uganda?
Provide a succinct answer. 1.15. In the year 1974, what is the difference between the Population (in %) in Myanmar and Population (in %) in Vietnam?
Give a very brief answer. -1.27. In the year 1974, what is the difference between the Population (in %) in Uganda and Population (in %) in Vietnam?
Provide a succinct answer. -2.42. In the year 1975, what is the difference between the Population (in %) in Lebanon and Population (in %) in Myanmar?
Offer a terse response. 1.15. In the year 1975, what is the difference between the Population (in %) in Lebanon and Population (in %) in Uganda?
Your answer should be compact. 2.31. In the year 1975, what is the difference between the Population (in %) in Lebanon and Population (in %) in Vietnam?
Ensure brevity in your answer.  -0.02. In the year 1975, what is the difference between the Population (in %) in Myanmar and Population (in %) in Uganda?
Your answer should be very brief. 1.16. In the year 1975, what is the difference between the Population (in %) in Myanmar and Population (in %) in Vietnam?
Make the answer very short. -1.16. In the year 1975, what is the difference between the Population (in %) of Uganda and Population (in %) of Vietnam?
Your response must be concise. -2.32. In the year 1976, what is the difference between the Population (in %) in Lebanon and Population (in %) in Myanmar?
Your response must be concise. 1.24. In the year 1976, what is the difference between the Population (in %) of Lebanon and Population (in %) of Uganda?
Offer a terse response. 2.41. In the year 1976, what is the difference between the Population (in %) in Lebanon and Population (in %) in Vietnam?
Ensure brevity in your answer.  0.02. In the year 1976, what is the difference between the Population (in %) of Myanmar and Population (in %) of Uganda?
Your answer should be compact. 1.18. In the year 1976, what is the difference between the Population (in %) in Myanmar and Population (in %) in Vietnam?
Provide a succinct answer. -1.22. In the year 1976, what is the difference between the Population (in %) of Uganda and Population (in %) of Vietnam?
Your answer should be compact. -2.39. In the year 1977, what is the difference between the Population (in %) of Lebanon and Population (in %) of Myanmar?
Make the answer very short. 1.35. In the year 1977, what is the difference between the Population (in %) in Lebanon and Population (in %) in Uganda?
Your answer should be compact. 2.54. In the year 1977, what is the difference between the Population (in %) of Lebanon and Population (in %) of Vietnam?
Provide a succinct answer. 0.06. In the year 1977, what is the difference between the Population (in %) in Myanmar and Population (in %) in Uganda?
Provide a succinct answer. 1.19. In the year 1977, what is the difference between the Population (in %) of Myanmar and Population (in %) of Vietnam?
Provide a short and direct response. -1.29. In the year 1977, what is the difference between the Population (in %) in Uganda and Population (in %) in Vietnam?
Keep it short and to the point. -2.47. In the year 1978, what is the difference between the Population (in %) in Lebanon and Population (in %) in Myanmar?
Offer a terse response. 1.46. In the year 1978, what is the difference between the Population (in %) of Lebanon and Population (in %) of Uganda?
Provide a short and direct response. 2.66. In the year 1978, what is the difference between the Population (in %) of Lebanon and Population (in %) of Vietnam?
Provide a succinct answer. 0.09. In the year 1978, what is the difference between the Population (in %) of Myanmar and Population (in %) of Uganda?
Provide a succinct answer. 1.2. In the year 1978, what is the difference between the Population (in %) in Myanmar and Population (in %) in Vietnam?
Offer a terse response. -1.36. In the year 1978, what is the difference between the Population (in %) of Uganda and Population (in %) of Vietnam?
Your answer should be compact. -2.56. What is the ratio of the Population (in %) in Myanmar in 1971 to that in 1972?
Ensure brevity in your answer.  0.99. What is the ratio of the Population (in %) in Uganda in 1971 to that in 1972?
Keep it short and to the point. 1. What is the ratio of the Population (in %) in Vietnam in 1971 to that in 1972?
Your answer should be compact. 1.02. What is the ratio of the Population (in %) of Lebanon in 1971 to that in 1973?
Ensure brevity in your answer.  1.01. What is the ratio of the Population (in %) in Myanmar in 1971 to that in 1973?
Give a very brief answer. 0.98. What is the ratio of the Population (in %) of Uganda in 1971 to that in 1973?
Ensure brevity in your answer.  0.99. What is the ratio of the Population (in %) of Vietnam in 1971 to that in 1973?
Keep it short and to the point. 1.04. What is the ratio of the Population (in %) in Lebanon in 1971 to that in 1974?
Provide a succinct answer. 1.02. What is the ratio of the Population (in %) of Myanmar in 1971 to that in 1974?
Offer a very short reply. 0.98. What is the ratio of the Population (in %) of Vietnam in 1971 to that in 1974?
Keep it short and to the point. 1.06. What is the ratio of the Population (in %) in Lebanon in 1971 to that in 1975?
Provide a short and direct response. 1.02. What is the ratio of the Population (in %) in Myanmar in 1971 to that in 1975?
Keep it short and to the point. 0.98. What is the ratio of the Population (in %) of Vietnam in 1971 to that in 1975?
Make the answer very short. 1.08. What is the ratio of the Population (in %) of Lebanon in 1971 to that in 1976?
Your response must be concise. 1. What is the ratio of the Population (in %) of Myanmar in 1971 to that in 1976?
Keep it short and to the point. 0.97. What is the ratio of the Population (in %) of Uganda in 1971 to that in 1976?
Your response must be concise. 0.99. What is the ratio of the Population (in %) in Vietnam in 1971 to that in 1976?
Offer a terse response. 1.06. What is the ratio of the Population (in %) in Lebanon in 1971 to that in 1977?
Offer a terse response. 0.97. What is the ratio of the Population (in %) of Myanmar in 1971 to that in 1977?
Keep it short and to the point. 0.97. What is the ratio of the Population (in %) in Uganda in 1971 to that in 1977?
Keep it short and to the point. 0.99. What is the ratio of the Population (in %) in Vietnam in 1971 to that in 1977?
Keep it short and to the point. 1.04. What is the ratio of the Population (in %) of Lebanon in 1971 to that in 1978?
Your answer should be compact. 0.95. What is the ratio of the Population (in %) in Myanmar in 1971 to that in 1978?
Provide a succinct answer. 0.96. What is the ratio of the Population (in %) of Vietnam in 1971 to that in 1978?
Your response must be concise. 1.03. What is the ratio of the Population (in %) in Lebanon in 1972 to that in 1973?
Your answer should be compact. 1.01. What is the ratio of the Population (in %) in Myanmar in 1972 to that in 1973?
Provide a succinct answer. 0.99. What is the ratio of the Population (in %) in Vietnam in 1972 to that in 1973?
Keep it short and to the point. 1.02. What is the ratio of the Population (in %) in Lebanon in 1972 to that in 1974?
Ensure brevity in your answer.  1.01. What is the ratio of the Population (in %) in Vietnam in 1972 to that in 1974?
Ensure brevity in your answer.  1.04. What is the ratio of the Population (in %) in Lebanon in 1972 to that in 1975?
Provide a short and direct response. 1.02. What is the ratio of the Population (in %) in Uganda in 1972 to that in 1975?
Keep it short and to the point. 1. What is the ratio of the Population (in %) in Vietnam in 1972 to that in 1975?
Provide a short and direct response. 1.06. What is the ratio of the Population (in %) of Myanmar in 1972 to that in 1976?
Provide a short and direct response. 0.98. What is the ratio of the Population (in %) of Uganda in 1972 to that in 1976?
Keep it short and to the point. 1. What is the ratio of the Population (in %) of Vietnam in 1972 to that in 1976?
Keep it short and to the point. 1.05. What is the ratio of the Population (in %) of Myanmar in 1972 to that in 1977?
Give a very brief answer. 0.98. What is the ratio of the Population (in %) in Uganda in 1972 to that in 1977?
Your answer should be compact. 0.99. What is the ratio of the Population (in %) of Vietnam in 1972 to that in 1977?
Give a very brief answer. 1.03. What is the ratio of the Population (in %) of Lebanon in 1972 to that in 1978?
Make the answer very short. 0.95. What is the ratio of the Population (in %) of Myanmar in 1972 to that in 1978?
Your answer should be compact. 0.97. What is the ratio of the Population (in %) of Vietnam in 1972 to that in 1978?
Provide a short and direct response. 1.01. What is the ratio of the Population (in %) in Lebanon in 1973 to that in 1974?
Ensure brevity in your answer.  1.01. What is the ratio of the Population (in %) in Myanmar in 1973 to that in 1974?
Offer a very short reply. 1. What is the ratio of the Population (in %) in Uganda in 1973 to that in 1974?
Provide a succinct answer. 1. What is the ratio of the Population (in %) in Vietnam in 1973 to that in 1974?
Ensure brevity in your answer.  1.02. What is the ratio of the Population (in %) in Lebanon in 1973 to that in 1975?
Provide a succinct answer. 1.01. What is the ratio of the Population (in %) in Myanmar in 1973 to that in 1975?
Provide a short and direct response. 0.99. What is the ratio of the Population (in %) of Uganda in 1973 to that in 1975?
Give a very brief answer. 1. What is the ratio of the Population (in %) in Vietnam in 1973 to that in 1975?
Provide a succinct answer. 1.04. What is the ratio of the Population (in %) in Myanmar in 1973 to that in 1976?
Offer a very short reply. 0.99. What is the ratio of the Population (in %) in Vietnam in 1973 to that in 1976?
Offer a terse response. 1.02. What is the ratio of the Population (in %) in Lebanon in 1973 to that in 1977?
Make the answer very short. 0.96. What is the ratio of the Population (in %) of Myanmar in 1973 to that in 1977?
Your answer should be very brief. 0.98. What is the ratio of the Population (in %) of Uganda in 1973 to that in 1977?
Your answer should be very brief. 1. What is the ratio of the Population (in %) in Lebanon in 1973 to that in 1978?
Give a very brief answer. 0.94. What is the ratio of the Population (in %) of Myanmar in 1973 to that in 1978?
Your response must be concise. 0.98. What is the ratio of the Population (in %) of Uganda in 1973 to that in 1978?
Ensure brevity in your answer.  1. What is the ratio of the Population (in %) in Myanmar in 1974 to that in 1975?
Your answer should be very brief. 1. What is the ratio of the Population (in %) in Uganda in 1974 to that in 1975?
Give a very brief answer. 1. What is the ratio of the Population (in %) in Vietnam in 1974 to that in 1975?
Ensure brevity in your answer.  1.02. What is the ratio of the Population (in %) of Lebanon in 1974 to that in 1976?
Your answer should be very brief. 0.98. What is the ratio of the Population (in %) of Uganda in 1974 to that in 1976?
Provide a succinct answer. 1. What is the ratio of the Population (in %) in Vietnam in 1974 to that in 1976?
Your answer should be compact. 1. What is the ratio of the Population (in %) in Lebanon in 1974 to that in 1977?
Your response must be concise. 0.96. What is the ratio of the Population (in %) in Myanmar in 1974 to that in 1977?
Make the answer very short. 0.99. What is the ratio of the Population (in %) of Vietnam in 1974 to that in 1977?
Ensure brevity in your answer.  0.99. What is the ratio of the Population (in %) in Lebanon in 1974 to that in 1978?
Make the answer very short. 0.93. What is the ratio of the Population (in %) in Uganda in 1974 to that in 1978?
Provide a succinct answer. 1. What is the ratio of the Population (in %) of Vietnam in 1974 to that in 1978?
Offer a terse response. 0.97. What is the ratio of the Population (in %) in Lebanon in 1975 to that in 1976?
Offer a very short reply. 0.98. What is the ratio of the Population (in %) of Vietnam in 1975 to that in 1976?
Your response must be concise. 0.98. What is the ratio of the Population (in %) of Lebanon in 1975 to that in 1977?
Your answer should be very brief. 0.95. What is the ratio of the Population (in %) of Vietnam in 1975 to that in 1977?
Offer a terse response. 0.97. What is the ratio of the Population (in %) of Lebanon in 1975 to that in 1978?
Offer a terse response. 0.93. What is the ratio of the Population (in %) in Myanmar in 1975 to that in 1978?
Offer a very short reply. 0.98. What is the ratio of the Population (in %) in Uganda in 1975 to that in 1978?
Make the answer very short. 0.99. What is the ratio of the Population (in %) in Vietnam in 1975 to that in 1978?
Ensure brevity in your answer.  0.95. What is the ratio of the Population (in %) of Lebanon in 1976 to that in 1977?
Provide a short and direct response. 0.98. What is the ratio of the Population (in %) in Myanmar in 1976 to that in 1977?
Ensure brevity in your answer.  1. What is the ratio of the Population (in %) in Vietnam in 1976 to that in 1977?
Make the answer very short. 0.98. What is the ratio of the Population (in %) of Lebanon in 1976 to that in 1978?
Provide a succinct answer. 0.95. What is the ratio of the Population (in %) in Vietnam in 1976 to that in 1978?
Keep it short and to the point. 0.97. What is the ratio of the Population (in %) of Lebanon in 1977 to that in 1978?
Give a very brief answer. 0.98. What is the ratio of the Population (in %) in Uganda in 1977 to that in 1978?
Ensure brevity in your answer.  1. What is the ratio of the Population (in %) in Vietnam in 1977 to that in 1978?
Give a very brief answer. 0.98. What is the difference between the highest and the second highest Population (in %) in Lebanon?
Provide a short and direct response. 0.12. What is the difference between the highest and the second highest Population (in %) of Myanmar?
Your response must be concise. 0.01. What is the difference between the highest and the second highest Population (in %) of Uganda?
Provide a short and direct response. 0. What is the difference between the highest and the second highest Population (in %) of Vietnam?
Offer a terse response. 0.09. What is the difference between the highest and the lowest Population (in %) in Lebanon?
Ensure brevity in your answer.  0.37. What is the difference between the highest and the lowest Population (in %) in Myanmar?
Give a very brief answer. 0.14. What is the difference between the highest and the lowest Population (in %) in Uganda?
Offer a terse response. 0.03. What is the difference between the highest and the lowest Population (in %) of Vietnam?
Make the answer very short. 0.39. 